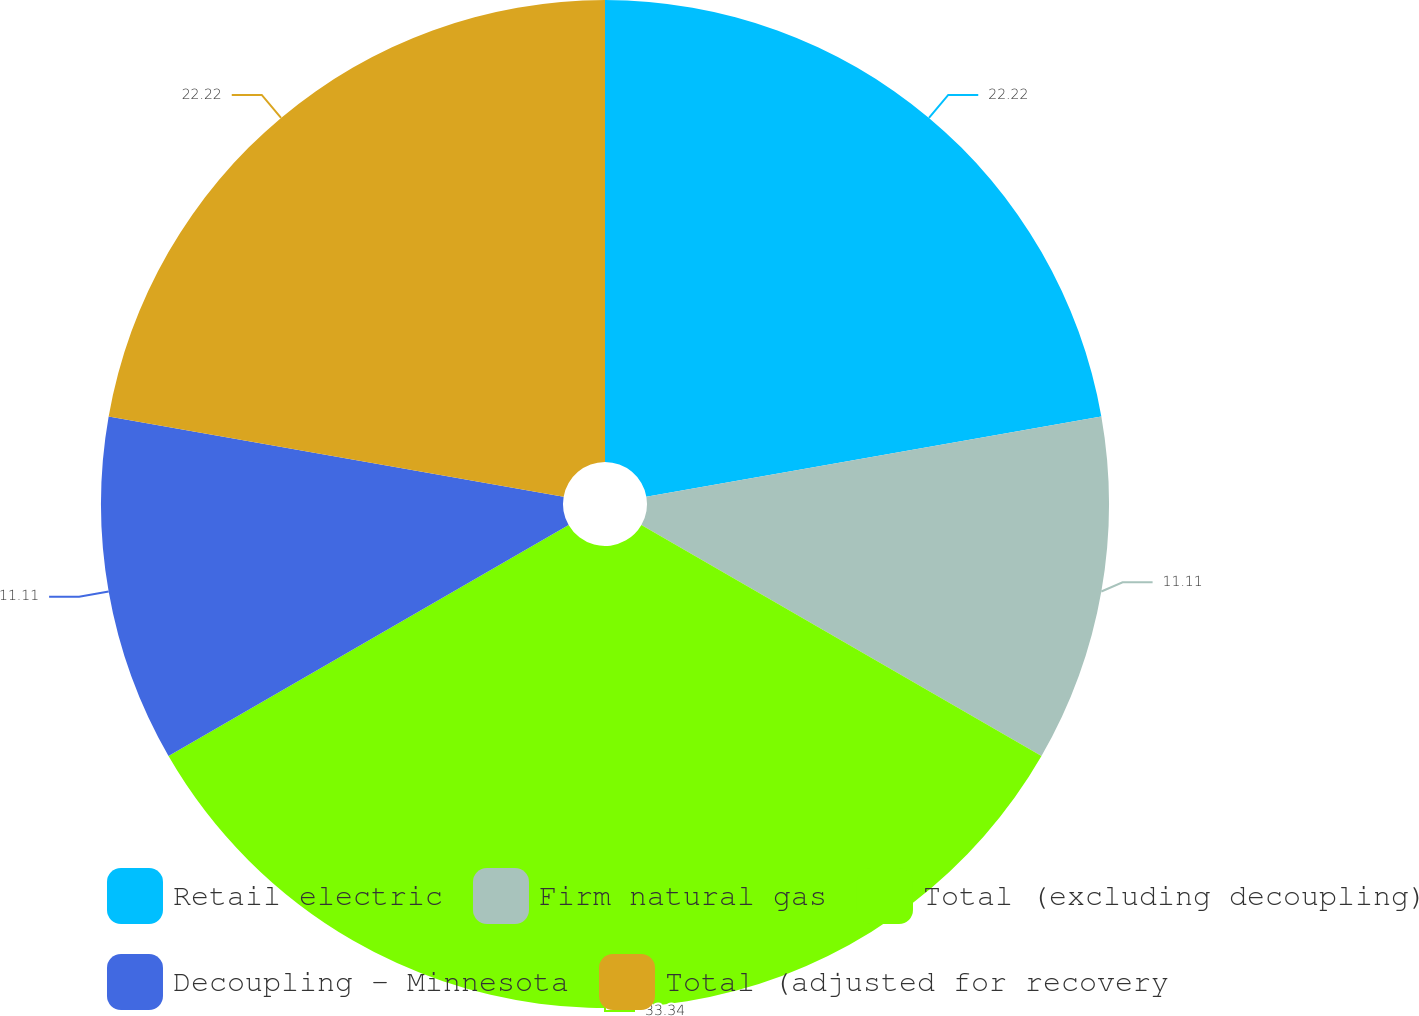Convert chart to OTSL. <chart><loc_0><loc_0><loc_500><loc_500><pie_chart><fcel>Retail electric<fcel>Firm natural gas<fcel>Total (excluding decoupling)<fcel>Decoupling - Minnesota<fcel>Total (adjusted for recovery<nl><fcel>22.22%<fcel>11.11%<fcel>33.33%<fcel>11.11%<fcel>22.22%<nl></chart> 